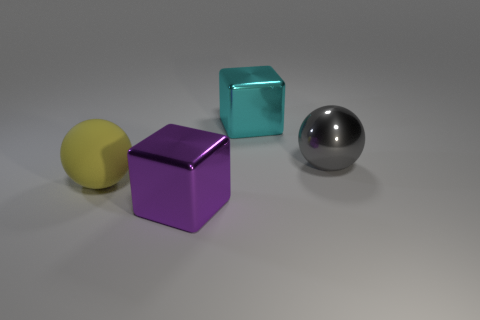Is the number of big cyan blocks in front of the cyan metal thing the same as the number of spheres?
Give a very brief answer. No. How many big metallic things are in front of the large cyan metal object and on the right side of the purple metal block?
Provide a succinct answer. 1. There is another thing that is the same shape as the big purple thing; what is its size?
Make the answer very short. Large. What number of other large objects are the same material as the gray object?
Your response must be concise. 2. Are there fewer yellow things that are on the right side of the cyan block than big shiny objects?
Give a very brief answer. Yes. What number of big purple things are there?
Ensure brevity in your answer.  1. What number of big cubes are the same color as the large shiny ball?
Give a very brief answer. 0. Is the big matte thing the same shape as the purple metal thing?
Keep it short and to the point. No. How big is the metallic cube right of the metal block left of the cyan cube?
Your response must be concise. Large. Is there a purple cube of the same size as the gray shiny ball?
Offer a terse response. Yes. 